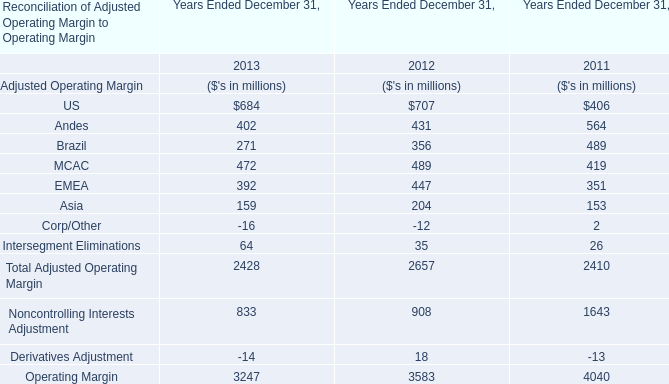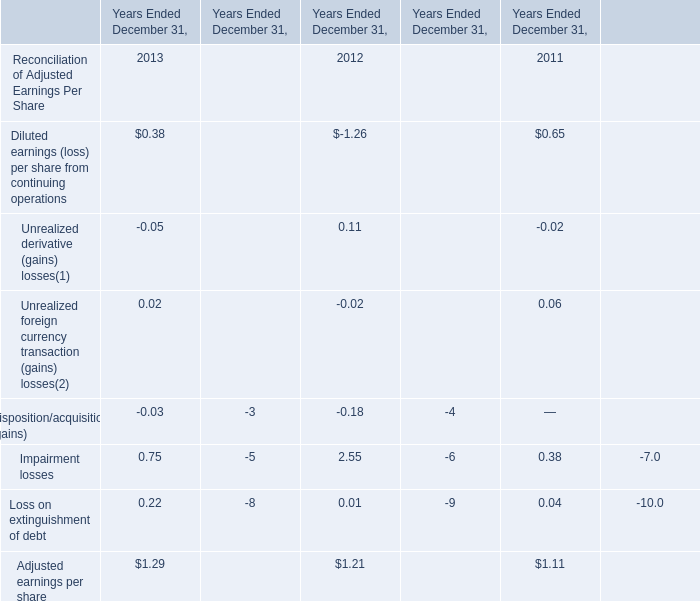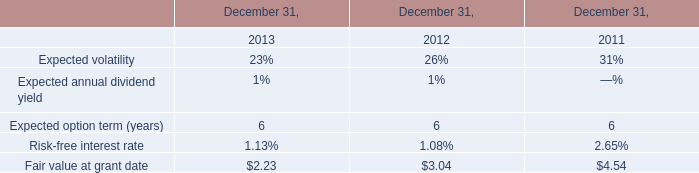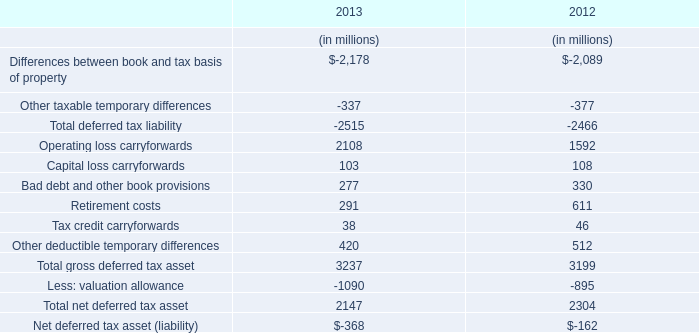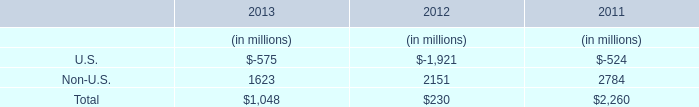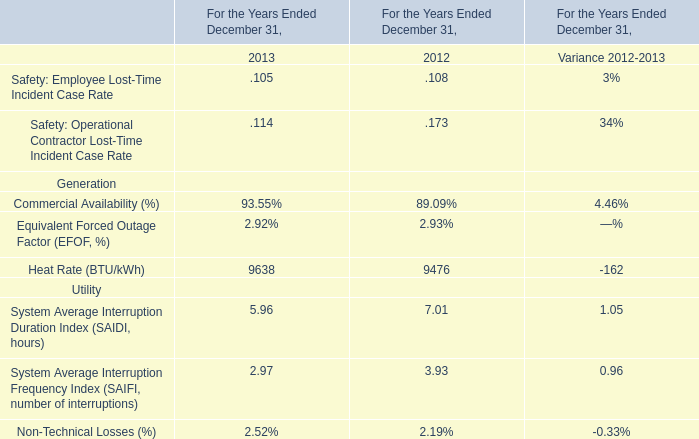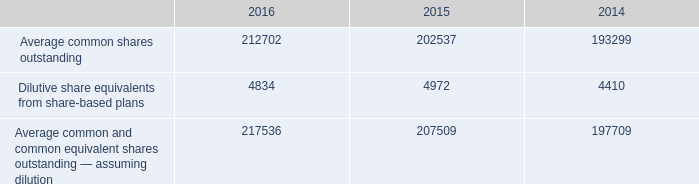What's the total amount of Andes,Brazil, MCAC and EMEA for Adjusted Operating Margin in 2013? (in million) 
Computations: (((402 + 271) + 472) + 392)
Answer: 1537.0. 